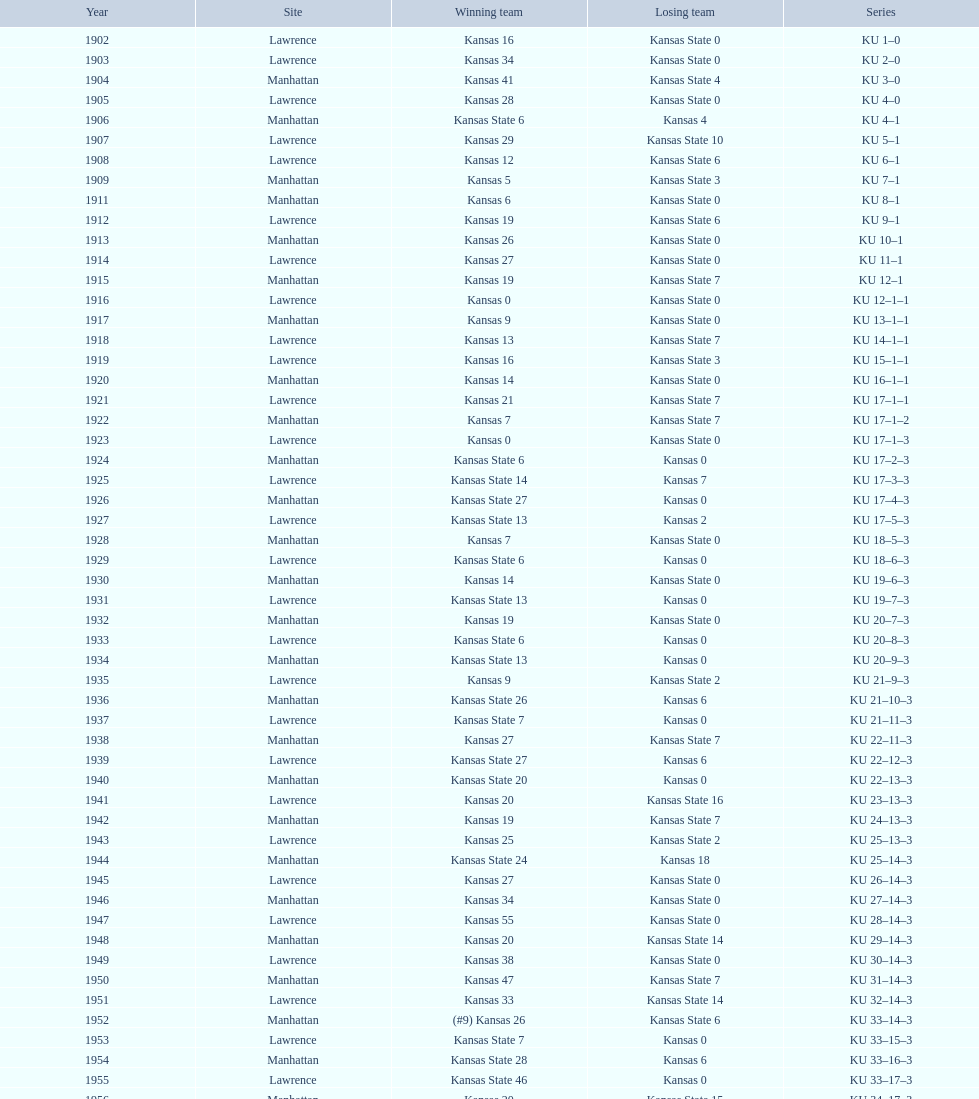How many times did kansas beat kansas state before 1910? 7. 